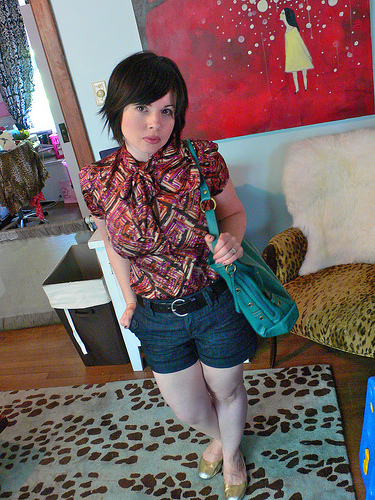<image>
Is there a painting above the bag? No. The painting is not positioned above the bag. The vertical arrangement shows a different relationship. 